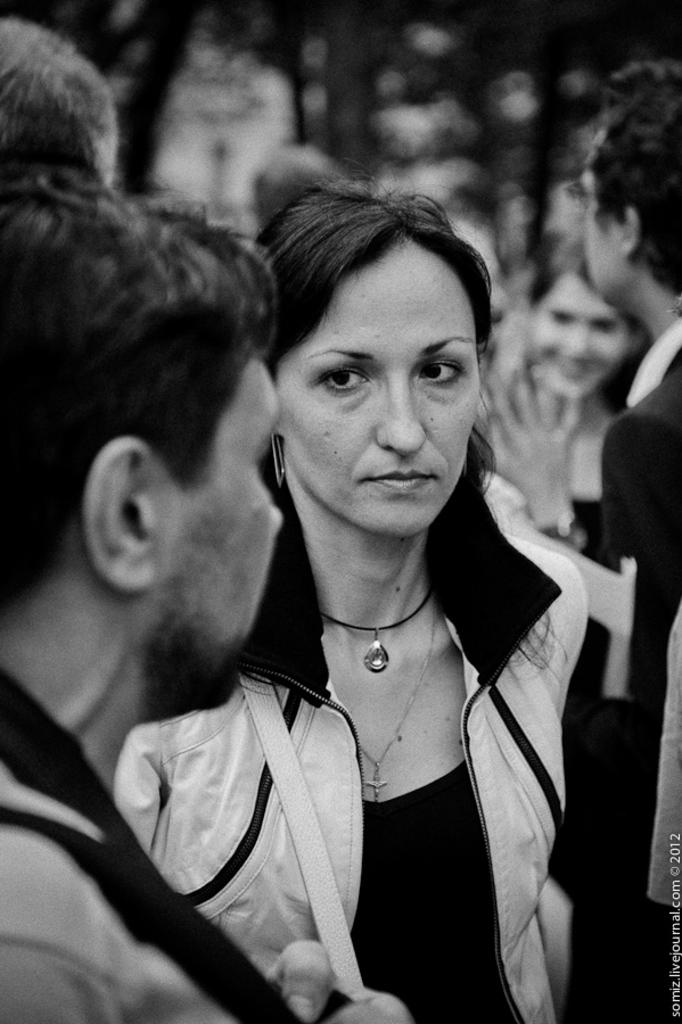What is the color scheme of the image? The image is black and white. What is the woman in the image wearing? The woman is wearing a jacket. Where is the woman positioned in the image? The woman is standing in the middle of the image. Are there any other people in the image? Yes, there are people standing on either side of the woman. Is the woman taking a bath in the image? No, there is no indication of a bath or any water-related activity in the image. 